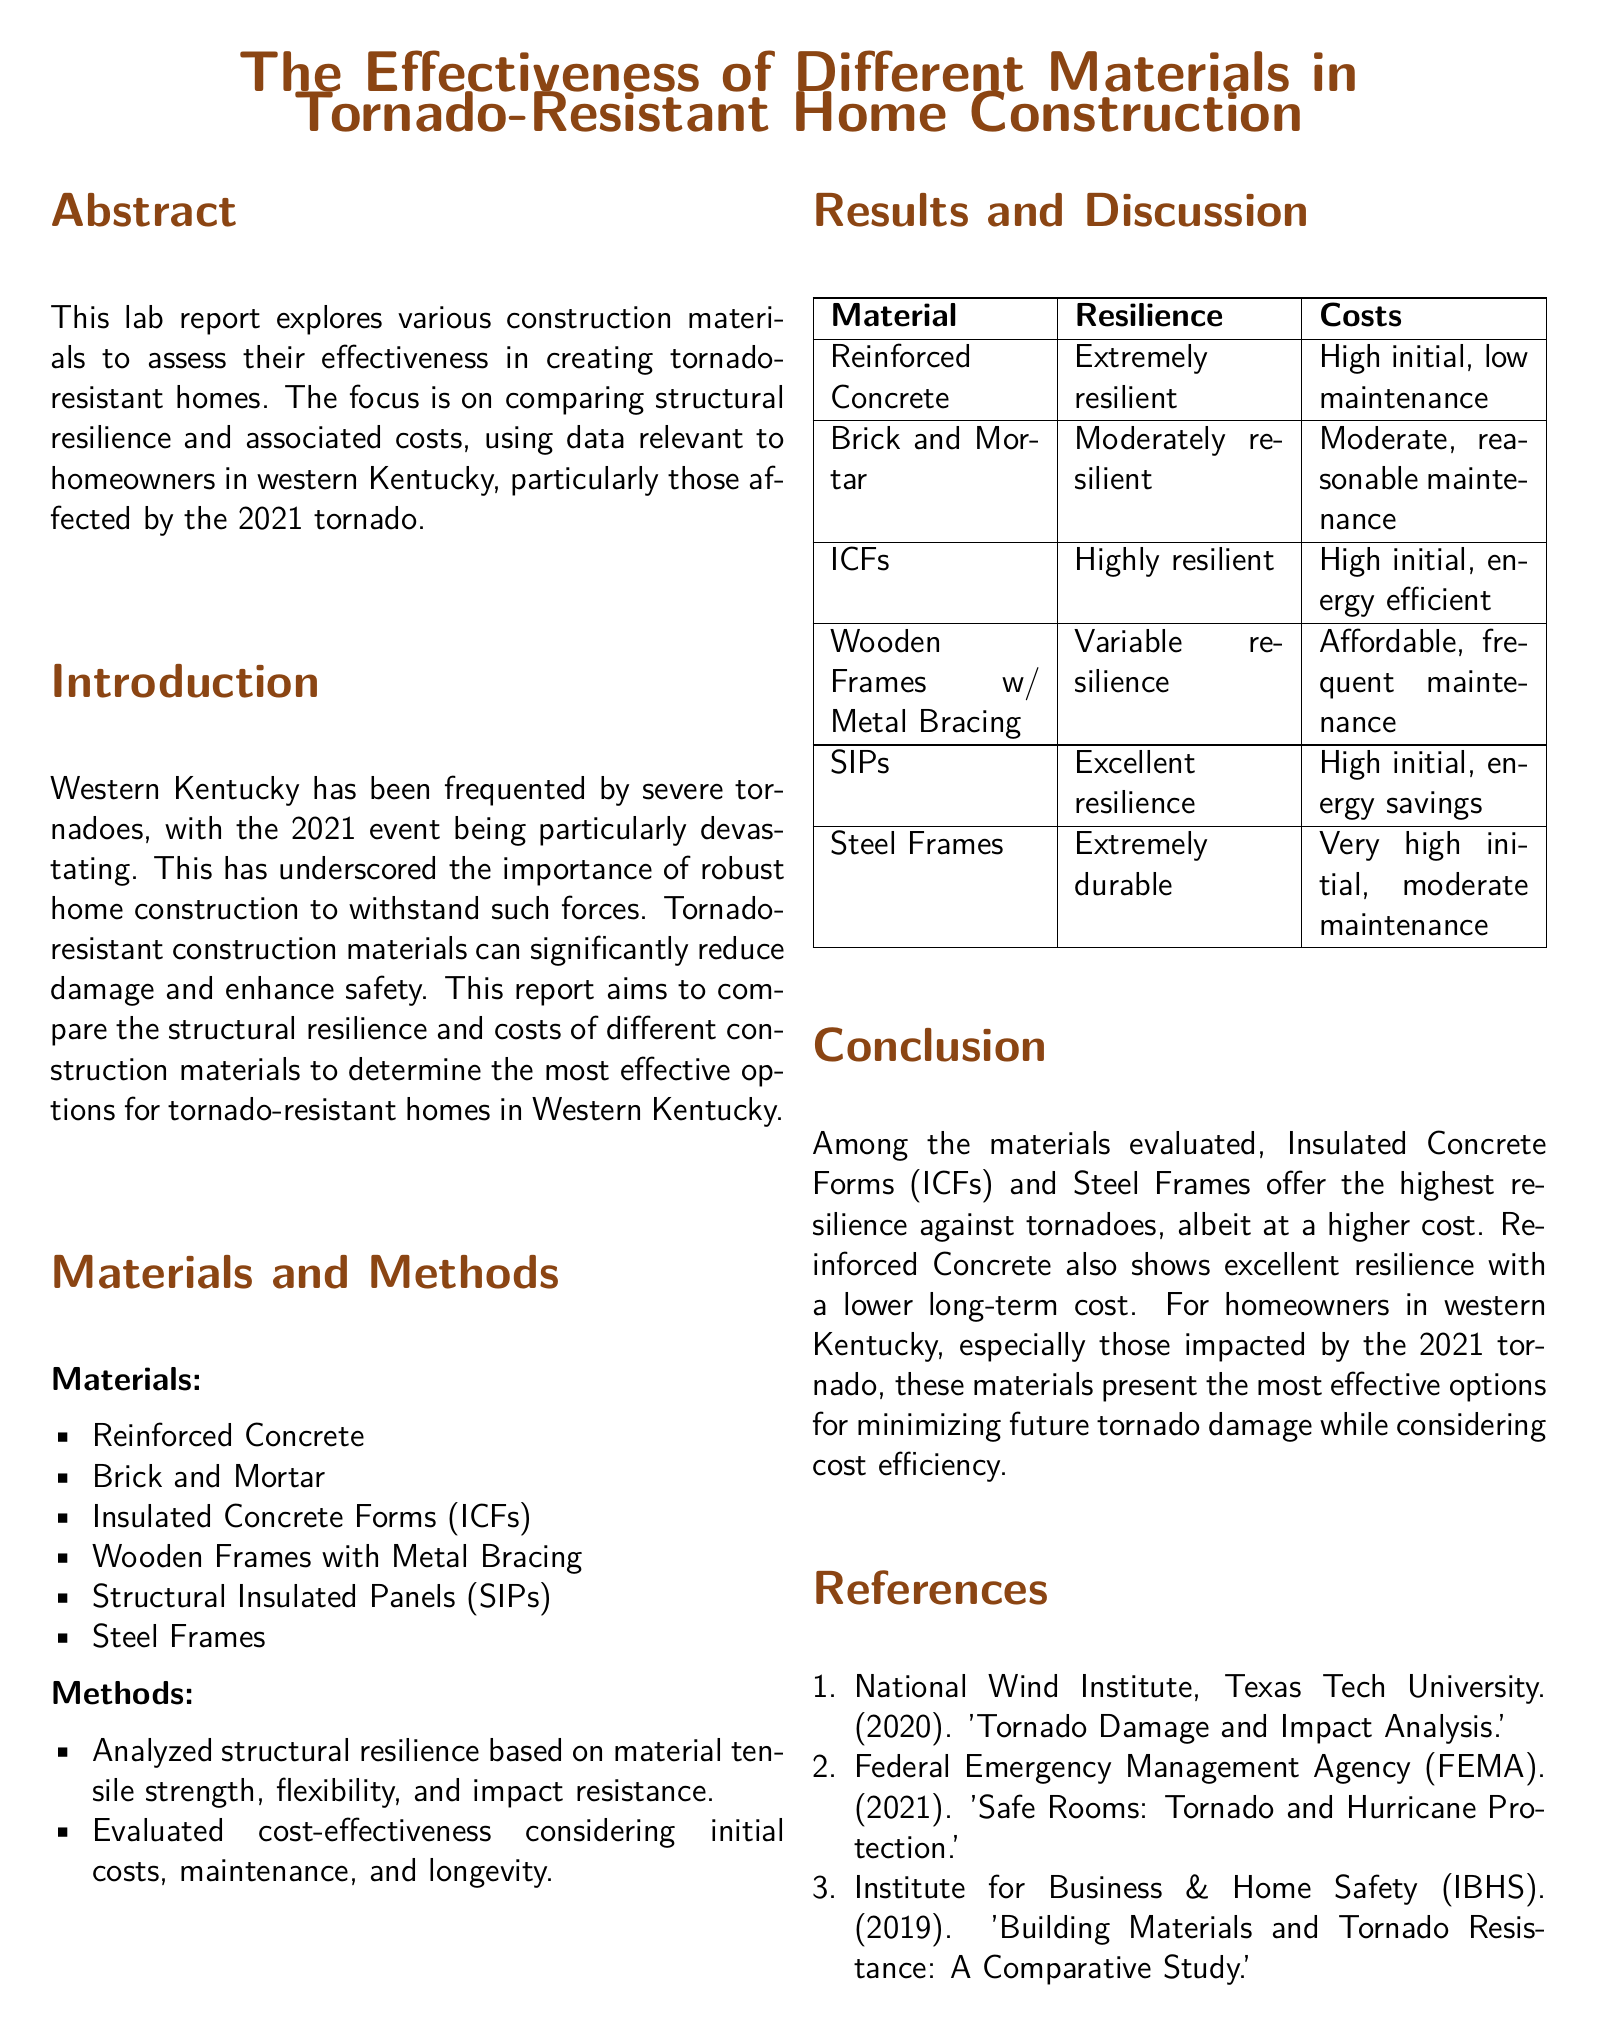what is the main focus of the lab report? The main focus of the lab report is to compare the structural resilience and costs of different construction materials for tornado-resistant homes.
Answer: comparison of structural resilience and costs which two materials offer the highest resilience? The materials that offer the highest resilience are Insulated Concrete Forms (ICFs) and Steel Frames.
Answer: ICFs and Steel Frames what type of construction material is considered affordable with frequent maintenance? The type of construction material considered affordable with frequent maintenance is Wooden Frames with Metal Bracing.
Answer: Wooden Frames with Metal Bracing how many references are provided in the document? The number of references provided in the document is three.
Answer: three what is the initial cost of Reinforced Concrete described as? The initial cost of Reinforced Concrete is described as high.
Answer: high which material is noted for being energy efficient? The material noted for being energy efficient is Insulated Concrete Forms (ICFs).
Answer: Insulated Concrete Forms (ICFs) what is the main implication of this report for homeowners in western Kentucky? The main implication of this report is that certain materials can minimize future tornado damage while considering cost efficiency.
Answer: minimize future tornado damage while considering cost efficiency what is the resilience of Brick and Mortar classified as? The resilience of Brick and Mortar is classified as moderately resilient.
Answer: moderately resilient 